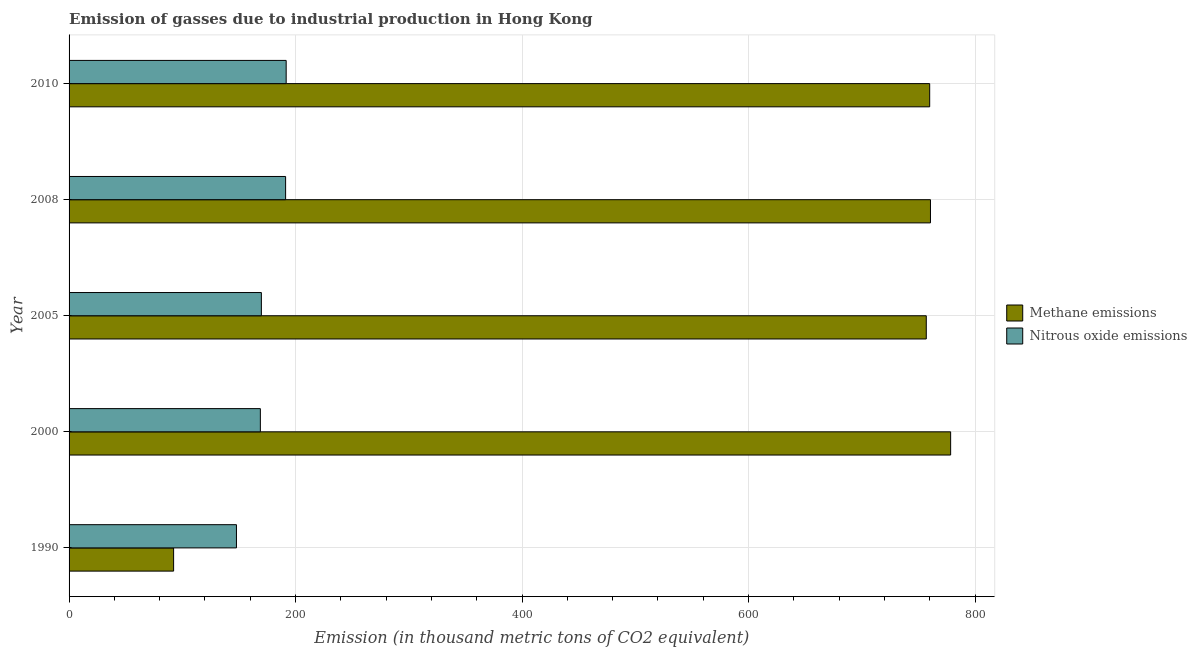How many different coloured bars are there?
Give a very brief answer. 2. Are the number of bars per tick equal to the number of legend labels?
Keep it short and to the point. Yes. Are the number of bars on each tick of the Y-axis equal?
Make the answer very short. Yes. How many bars are there on the 1st tick from the bottom?
Give a very brief answer. 2. What is the label of the 5th group of bars from the top?
Provide a succinct answer. 1990. In how many cases, is the number of bars for a given year not equal to the number of legend labels?
Your answer should be compact. 0. What is the amount of nitrous oxide emissions in 2000?
Your response must be concise. 168.9. Across all years, what is the maximum amount of methane emissions?
Offer a very short reply. 778.4. Across all years, what is the minimum amount of nitrous oxide emissions?
Provide a succinct answer. 147.8. What is the total amount of methane emissions in the graph?
Offer a terse response. 3148.1. What is the difference between the amount of nitrous oxide emissions in 2000 and the amount of methane emissions in 2010?
Offer a very short reply. -591. What is the average amount of nitrous oxide emissions per year?
Offer a very short reply. 173.88. In the year 1990, what is the difference between the amount of methane emissions and amount of nitrous oxide emissions?
Your response must be concise. -55.5. What is the ratio of the amount of methane emissions in 1990 to that in 2010?
Make the answer very short. 0.12. What is the difference between the highest and the lowest amount of nitrous oxide emissions?
Your answer should be compact. 43.9. Is the sum of the amount of methane emissions in 2000 and 2008 greater than the maximum amount of nitrous oxide emissions across all years?
Make the answer very short. Yes. What does the 1st bar from the top in 2010 represents?
Offer a very short reply. Nitrous oxide emissions. What does the 2nd bar from the bottom in 1990 represents?
Provide a short and direct response. Nitrous oxide emissions. How many bars are there?
Give a very brief answer. 10. How many years are there in the graph?
Your response must be concise. 5. What is the difference between two consecutive major ticks on the X-axis?
Your answer should be very brief. 200. Are the values on the major ticks of X-axis written in scientific E-notation?
Provide a succinct answer. No. How many legend labels are there?
Offer a very short reply. 2. What is the title of the graph?
Ensure brevity in your answer.  Emission of gasses due to industrial production in Hong Kong. What is the label or title of the X-axis?
Provide a short and direct response. Emission (in thousand metric tons of CO2 equivalent). What is the Emission (in thousand metric tons of CO2 equivalent) in Methane emissions in 1990?
Make the answer very short. 92.3. What is the Emission (in thousand metric tons of CO2 equivalent) in Nitrous oxide emissions in 1990?
Offer a very short reply. 147.8. What is the Emission (in thousand metric tons of CO2 equivalent) of Methane emissions in 2000?
Your response must be concise. 778.4. What is the Emission (in thousand metric tons of CO2 equivalent) of Nitrous oxide emissions in 2000?
Provide a succinct answer. 168.9. What is the Emission (in thousand metric tons of CO2 equivalent) in Methane emissions in 2005?
Your response must be concise. 756.9. What is the Emission (in thousand metric tons of CO2 equivalent) in Nitrous oxide emissions in 2005?
Offer a terse response. 169.8. What is the Emission (in thousand metric tons of CO2 equivalent) of Methane emissions in 2008?
Your answer should be compact. 760.6. What is the Emission (in thousand metric tons of CO2 equivalent) of Nitrous oxide emissions in 2008?
Your answer should be very brief. 191.2. What is the Emission (in thousand metric tons of CO2 equivalent) in Methane emissions in 2010?
Make the answer very short. 759.9. What is the Emission (in thousand metric tons of CO2 equivalent) in Nitrous oxide emissions in 2010?
Keep it short and to the point. 191.7. Across all years, what is the maximum Emission (in thousand metric tons of CO2 equivalent) of Methane emissions?
Provide a short and direct response. 778.4. Across all years, what is the maximum Emission (in thousand metric tons of CO2 equivalent) of Nitrous oxide emissions?
Offer a very short reply. 191.7. Across all years, what is the minimum Emission (in thousand metric tons of CO2 equivalent) in Methane emissions?
Keep it short and to the point. 92.3. Across all years, what is the minimum Emission (in thousand metric tons of CO2 equivalent) in Nitrous oxide emissions?
Ensure brevity in your answer.  147.8. What is the total Emission (in thousand metric tons of CO2 equivalent) in Methane emissions in the graph?
Offer a very short reply. 3148.1. What is the total Emission (in thousand metric tons of CO2 equivalent) in Nitrous oxide emissions in the graph?
Your response must be concise. 869.4. What is the difference between the Emission (in thousand metric tons of CO2 equivalent) of Methane emissions in 1990 and that in 2000?
Give a very brief answer. -686.1. What is the difference between the Emission (in thousand metric tons of CO2 equivalent) of Nitrous oxide emissions in 1990 and that in 2000?
Give a very brief answer. -21.1. What is the difference between the Emission (in thousand metric tons of CO2 equivalent) of Methane emissions in 1990 and that in 2005?
Your answer should be compact. -664.6. What is the difference between the Emission (in thousand metric tons of CO2 equivalent) of Methane emissions in 1990 and that in 2008?
Your response must be concise. -668.3. What is the difference between the Emission (in thousand metric tons of CO2 equivalent) of Nitrous oxide emissions in 1990 and that in 2008?
Ensure brevity in your answer.  -43.4. What is the difference between the Emission (in thousand metric tons of CO2 equivalent) of Methane emissions in 1990 and that in 2010?
Provide a succinct answer. -667.6. What is the difference between the Emission (in thousand metric tons of CO2 equivalent) of Nitrous oxide emissions in 1990 and that in 2010?
Ensure brevity in your answer.  -43.9. What is the difference between the Emission (in thousand metric tons of CO2 equivalent) of Methane emissions in 2000 and that in 2005?
Offer a very short reply. 21.5. What is the difference between the Emission (in thousand metric tons of CO2 equivalent) of Nitrous oxide emissions in 2000 and that in 2008?
Offer a very short reply. -22.3. What is the difference between the Emission (in thousand metric tons of CO2 equivalent) in Nitrous oxide emissions in 2000 and that in 2010?
Offer a terse response. -22.8. What is the difference between the Emission (in thousand metric tons of CO2 equivalent) in Methane emissions in 2005 and that in 2008?
Make the answer very short. -3.7. What is the difference between the Emission (in thousand metric tons of CO2 equivalent) of Nitrous oxide emissions in 2005 and that in 2008?
Keep it short and to the point. -21.4. What is the difference between the Emission (in thousand metric tons of CO2 equivalent) of Methane emissions in 2005 and that in 2010?
Ensure brevity in your answer.  -3. What is the difference between the Emission (in thousand metric tons of CO2 equivalent) in Nitrous oxide emissions in 2005 and that in 2010?
Ensure brevity in your answer.  -21.9. What is the difference between the Emission (in thousand metric tons of CO2 equivalent) of Methane emissions in 2008 and that in 2010?
Give a very brief answer. 0.7. What is the difference between the Emission (in thousand metric tons of CO2 equivalent) in Methane emissions in 1990 and the Emission (in thousand metric tons of CO2 equivalent) in Nitrous oxide emissions in 2000?
Ensure brevity in your answer.  -76.6. What is the difference between the Emission (in thousand metric tons of CO2 equivalent) in Methane emissions in 1990 and the Emission (in thousand metric tons of CO2 equivalent) in Nitrous oxide emissions in 2005?
Your response must be concise. -77.5. What is the difference between the Emission (in thousand metric tons of CO2 equivalent) in Methane emissions in 1990 and the Emission (in thousand metric tons of CO2 equivalent) in Nitrous oxide emissions in 2008?
Your response must be concise. -98.9. What is the difference between the Emission (in thousand metric tons of CO2 equivalent) in Methane emissions in 1990 and the Emission (in thousand metric tons of CO2 equivalent) in Nitrous oxide emissions in 2010?
Your answer should be very brief. -99.4. What is the difference between the Emission (in thousand metric tons of CO2 equivalent) of Methane emissions in 2000 and the Emission (in thousand metric tons of CO2 equivalent) of Nitrous oxide emissions in 2005?
Make the answer very short. 608.6. What is the difference between the Emission (in thousand metric tons of CO2 equivalent) in Methane emissions in 2000 and the Emission (in thousand metric tons of CO2 equivalent) in Nitrous oxide emissions in 2008?
Your response must be concise. 587.2. What is the difference between the Emission (in thousand metric tons of CO2 equivalent) in Methane emissions in 2000 and the Emission (in thousand metric tons of CO2 equivalent) in Nitrous oxide emissions in 2010?
Your response must be concise. 586.7. What is the difference between the Emission (in thousand metric tons of CO2 equivalent) of Methane emissions in 2005 and the Emission (in thousand metric tons of CO2 equivalent) of Nitrous oxide emissions in 2008?
Provide a succinct answer. 565.7. What is the difference between the Emission (in thousand metric tons of CO2 equivalent) in Methane emissions in 2005 and the Emission (in thousand metric tons of CO2 equivalent) in Nitrous oxide emissions in 2010?
Give a very brief answer. 565.2. What is the difference between the Emission (in thousand metric tons of CO2 equivalent) of Methane emissions in 2008 and the Emission (in thousand metric tons of CO2 equivalent) of Nitrous oxide emissions in 2010?
Your answer should be compact. 568.9. What is the average Emission (in thousand metric tons of CO2 equivalent) of Methane emissions per year?
Provide a short and direct response. 629.62. What is the average Emission (in thousand metric tons of CO2 equivalent) of Nitrous oxide emissions per year?
Give a very brief answer. 173.88. In the year 1990, what is the difference between the Emission (in thousand metric tons of CO2 equivalent) of Methane emissions and Emission (in thousand metric tons of CO2 equivalent) of Nitrous oxide emissions?
Offer a terse response. -55.5. In the year 2000, what is the difference between the Emission (in thousand metric tons of CO2 equivalent) of Methane emissions and Emission (in thousand metric tons of CO2 equivalent) of Nitrous oxide emissions?
Your answer should be very brief. 609.5. In the year 2005, what is the difference between the Emission (in thousand metric tons of CO2 equivalent) of Methane emissions and Emission (in thousand metric tons of CO2 equivalent) of Nitrous oxide emissions?
Keep it short and to the point. 587.1. In the year 2008, what is the difference between the Emission (in thousand metric tons of CO2 equivalent) of Methane emissions and Emission (in thousand metric tons of CO2 equivalent) of Nitrous oxide emissions?
Ensure brevity in your answer.  569.4. In the year 2010, what is the difference between the Emission (in thousand metric tons of CO2 equivalent) in Methane emissions and Emission (in thousand metric tons of CO2 equivalent) in Nitrous oxide emissions?
Offer a terse response. 568.2. What is the ratio of the Emission (in thousand metric tons of CO2 equivalent) of Methane emissions in 1990 to that in 2000?
Ensure brevity in your answer.  0.12. What is the ratio of the Emission (in thousand metric tons of CO2 equivalent) of Nitrous oxide emissions in 1990 to that in 2000?
Your answer should be very brief. 0.88. What is the ratio of the Emission (in thousand metric tons of CO2 equivalent) of Methane emissions in 1990 to that in 2005?
Provide a succinct answer. 0.12. What is the ratio of the Emission (in thousand metric tons of CO2 equivalent) of Nitrous oxide emissions in 1990 to that in 2005?
Your answer should be compact. 0.87. What is the ratio of the Emission (in thousand metric tons of CO2 equivalent) in Methane emissions in 1990 to that in 2008?
Make the answer very short. 0.12. What is the ratio of the Emission (in thousand metric tons of CO2 equivalent) of Nitrous oxide emissions in 1990 to that in 2008?
Provide a short and direct response. 0.77. What is the ratio of the Emission (in thousand metric tons of CO2 equivalent) of Methane emissions in 1990 to that in 2010?
Keep it short and to the point. 0.12. What is the ratio of the Emission (in thousand metric tons of CO2 equivalent) in Nitrous oxide emissions in 1990 to that in 2010?
Provide a succinct answer. 0.77. What is the ratio of the Emission (in thousand metric tons of CO2 equivalent) of Methane emissions in 2000 to that in 2005?
Your answer should be compact. 1.03. What is the ratio of the Emission (in thousand metric tons of CO2 equivalent) of Methane emissions in 2000 to that in 2008?
Offer a terse response. 1.02. What is the ratio of the Emission (in thousand metric tons of CO2 equivalent) of Nitrous oxide emissions in 2000 to that in 2008?
Your answer should be compact. 0.88. What is the ratio of the Emission (in thousand metric tons of CO2 equivalent) in Methane emissions in 2000 to that in 2010?
Make the answer very short. 1.02. What is the ratio of the Emission (in thousand metric tons of CO2 equivalent) of Nitrous oxide emissions in 2000 to that in 2010?
Provide a short and direct response. 0.88. What is the ratio of the Emission (in thousand metric tons of CO2 equivalent) of Nitrous oxide emissions in 2005 to that in 2008?
Your response must be concise. 0.89. What is the ratio of the Emission (in thousand metric tons of CO2 equivalent) of Nitrous oxide emissions in 2005 to that in 2010?
Your response must be concise. 0.89. What is the difference between the highest and the second highest Emission (in thousand metric tons of CO2 equivalent) of Methane emissions?
Your answer should be compact. 17.8. What is the difference between the highest and the second highest Emission (in thousand metric tons of CO2 equivalent) of Nitrous oxide emissions?
Your answer should be compact. 0.5. What is the difference between the highest and the lowest Emission (in thousand metric tons of CO2 equivalent) of Methane emissions?
Ensure brevity in your answer.  686.1. What is the difference between the highest and the lowest Emission (in thousand metric tons of CO2 equivalent) of Nitrous oxide emissions?
Keep it short and to the point. 43.9. 